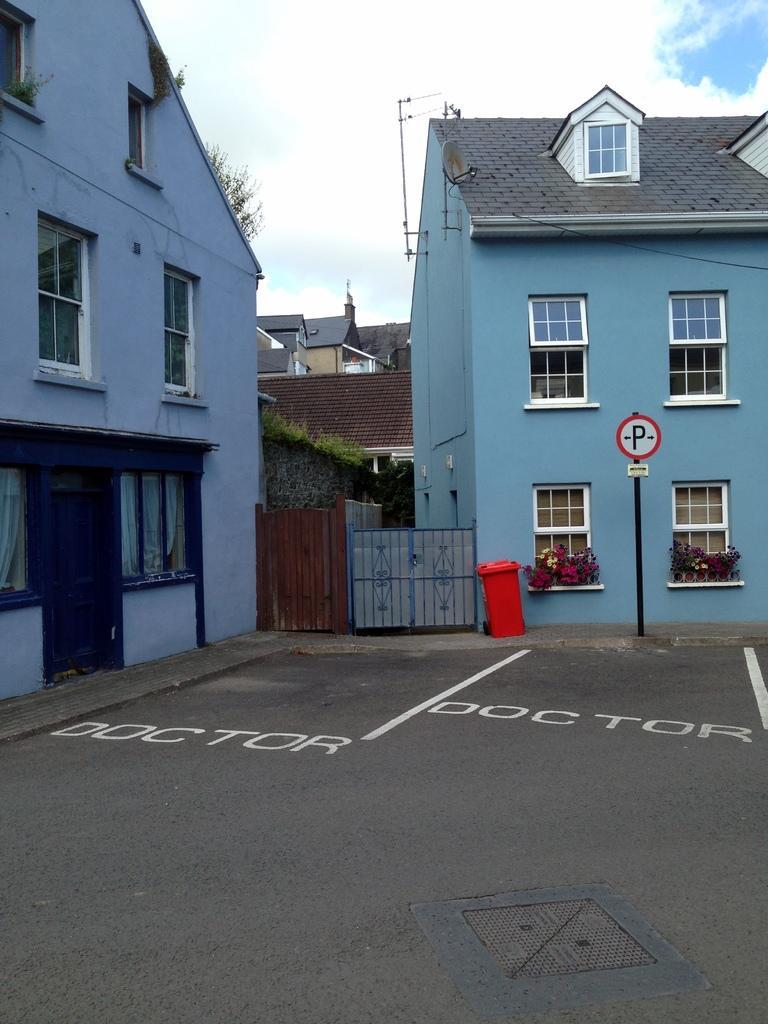Please provide a concise description of this image. In this image there is a road having some text and few lines are painted on it. There is a dustbin, beside there is a pole having a board attached to it are on the pavement. Behind there are few buildings. A building is having windows. Few windows are having few plants before it. Top of image there is sky with some clouds. 